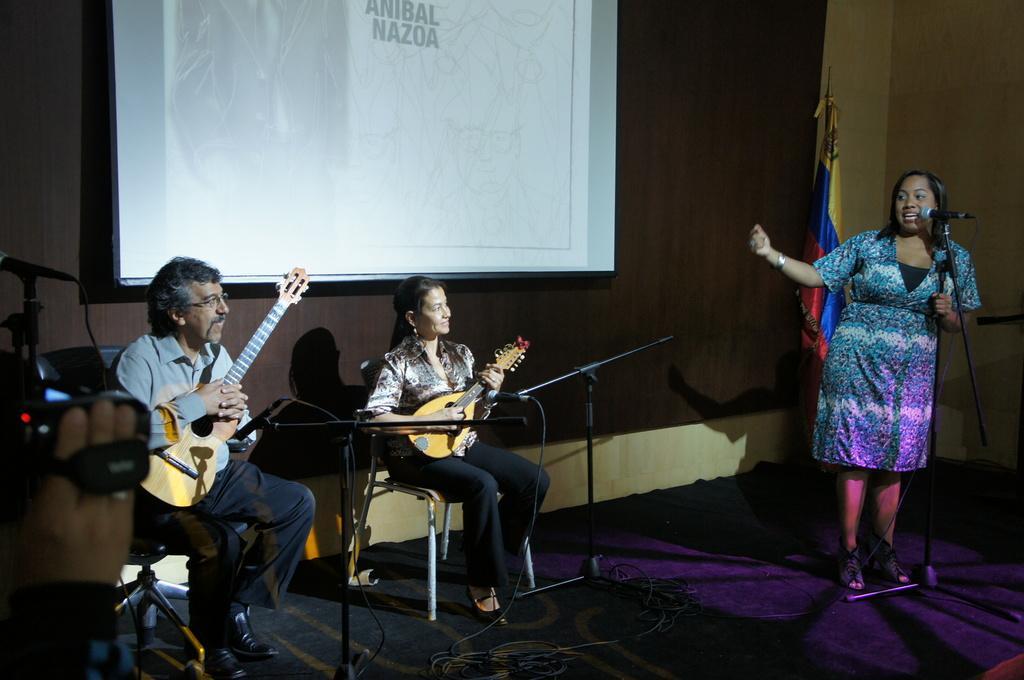In one or two sentences, can you explain what this image depicts? In this image i can see two women and a man, a woman standing and singing in front of a micro phone, a woman and a man holding a guitar at the back ground i can see a projector. 